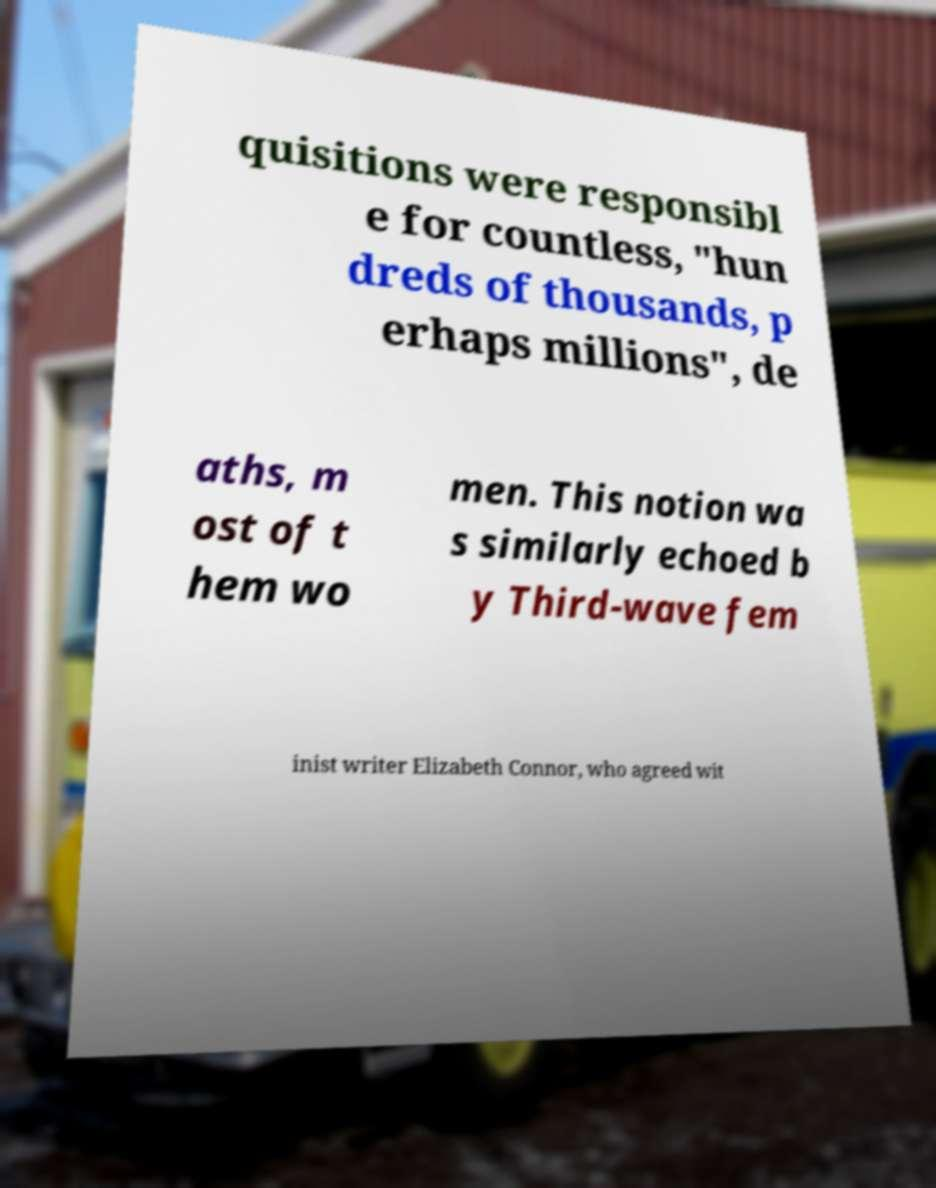Can you read and provide the text displayed in the image?This photo seems to have some interesting text. Can you extract and type it out for me? quisitions were responsibl e for countless, "hun dreds of thousands, p erhaps millions", de aths, m ost of t hem wo men. This notion wa s similarly echoed b y Third-wave fem inist writer Elizabeth Connor, who agreed wit 